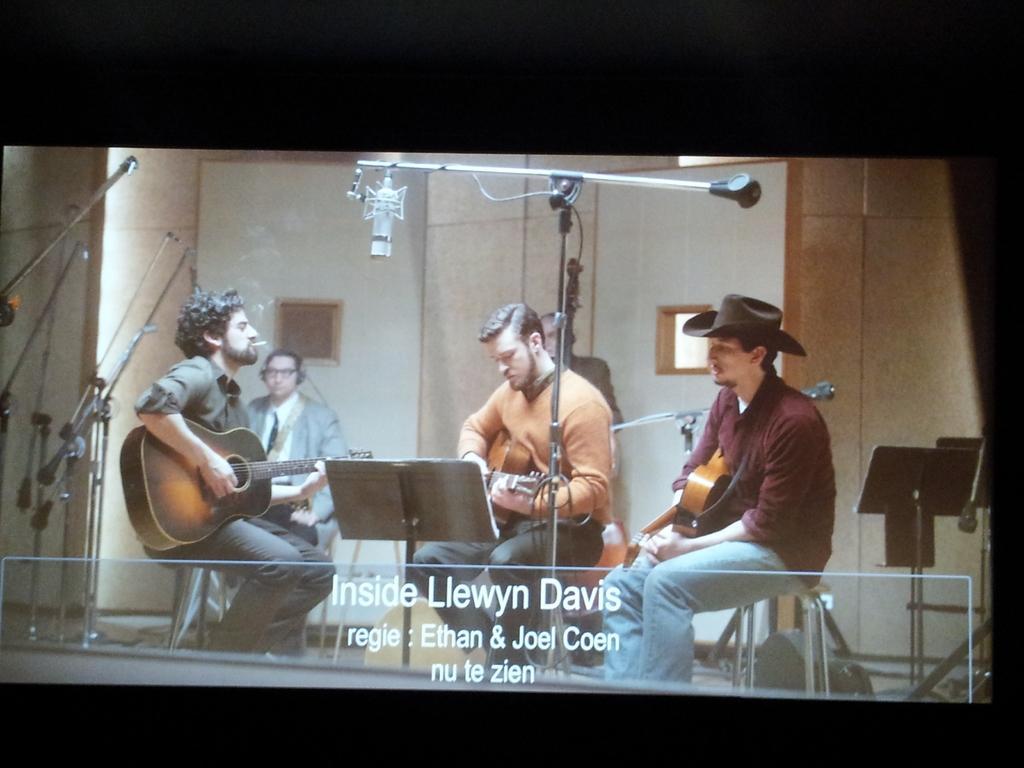In one or two sentences, can you explain what this image depicts? In this image we can see this people playing guitar and this person is smoking. There is a mic in front of them. In the background we can see a person sitting and wall. There are subtitles on the bottom of the image. 